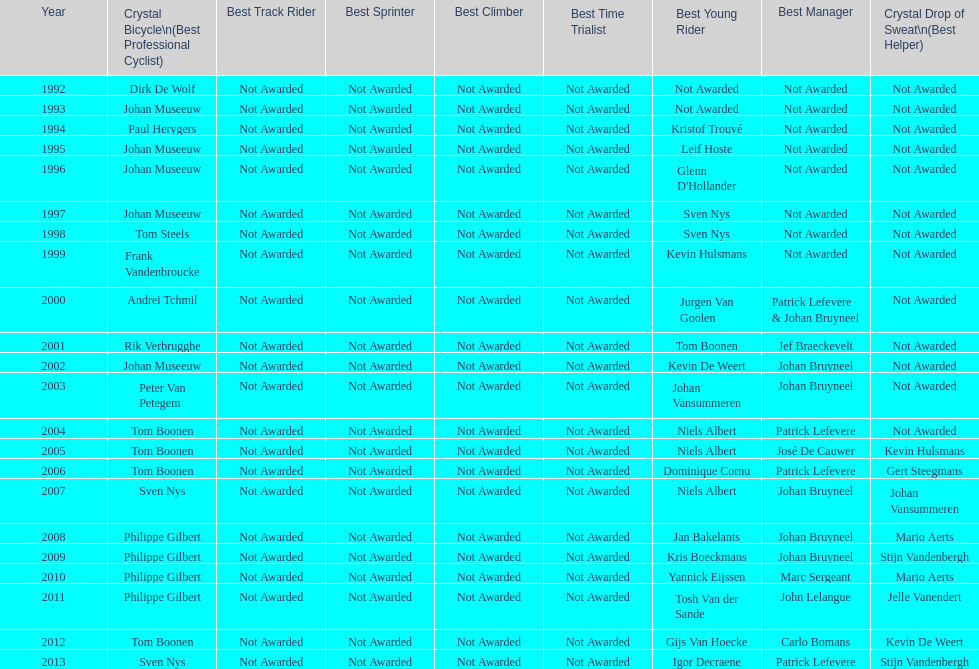Who has achieved the most best young rider distinctions? Niels Albert. 